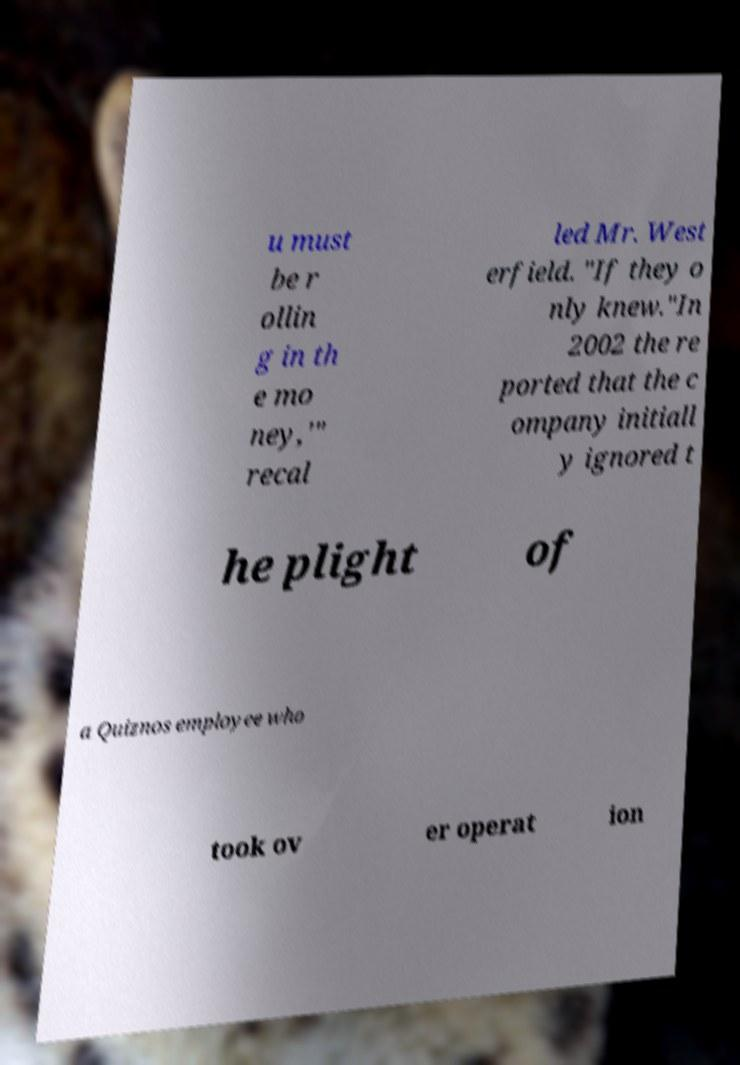Please identify and transcribe the text found in this image. u must be r ollin g in th e mo ney,'" recal led Mr. West erfield. "If they o nly knew."In 2002 the re ported that the c ompany initiall y ignored t he plight of a Quiznos employee who took ov er operat ion 